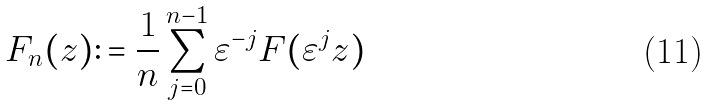<formula> <loc_0><loc_0><loc_500><loc_500>F _ { n } ( z ) \colon = \frac { 1 } { n } \sum _ { j = 0 } ^ { n - 1 } \varepsilon ^ { - j } F ( \varepsilon ^ { j } z )</formula> 